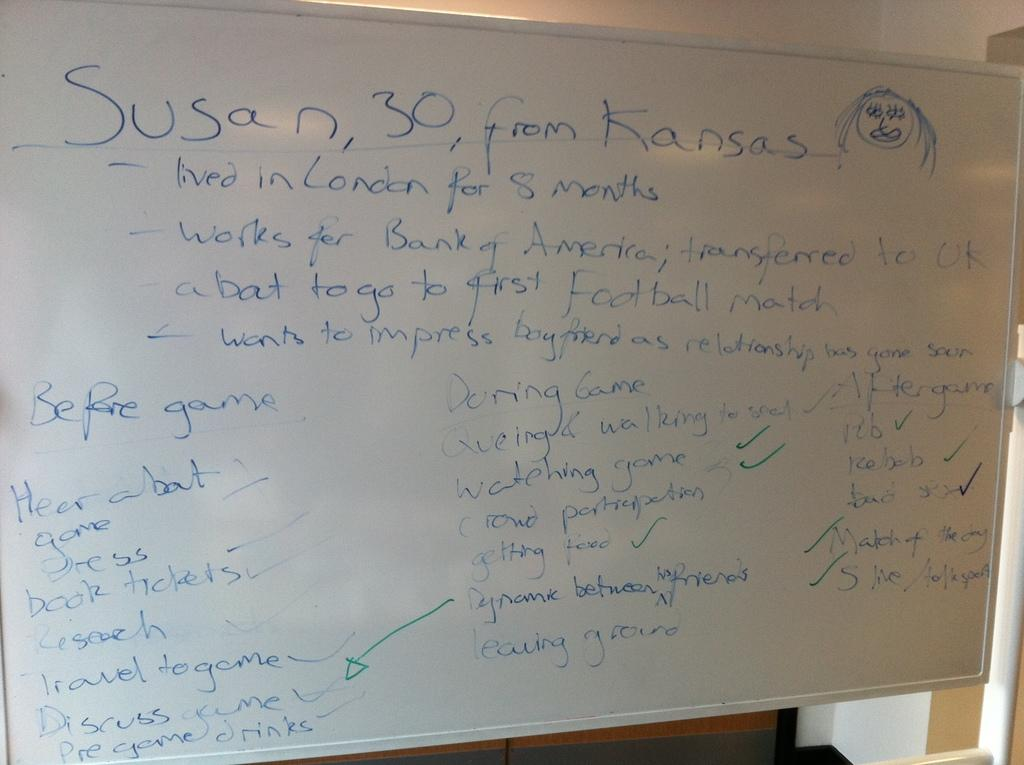<image>
Describe the image concisely. a write board with a lot of writing on it with the top saying susan,30, from kansas 